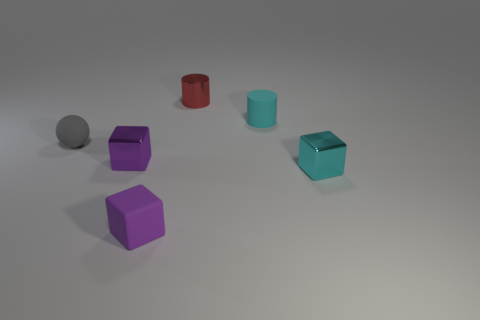The tiny object that is the same color as the small rubber cylinder is what shape?
Ensure brevity in your answer.  Cube. There is a shiny object that is the same color as the matte cube; what is its size?
Keep it short and to the point. Small. Is the small red thing the same shape as the tiny cyan rubber thing?
Make the answer very short. Yes. There is a gray object that is on the left side of the tiny purple matte thing; what material is it?
Provide a short and direct response. Rubber. There is a purple thing behind the rubber block; does it have the same size as the cyan thing that is behind the gray object?
Give a very brief answer. Yes. What color is the other thing that is the same shape as the small cyan rubber thing?
Your answer should be very brief. Red. Is the number of things left of the tiny purple rubber object greater than the number of tiny cyan metallic blocks that are to the left of the shiny cylinder?
Ensure brevity in your answer.  Yes. How many other objects are the same shape as the tiny gray thing?
Provide a short and direct response. 0. Is there a metallic thing to the right of the tiny cyan thing that is in front of the cyan matte thing?
Your answer should be very brief. No. How many small purple blocks are there?
Provide a succinct answer. 2. 